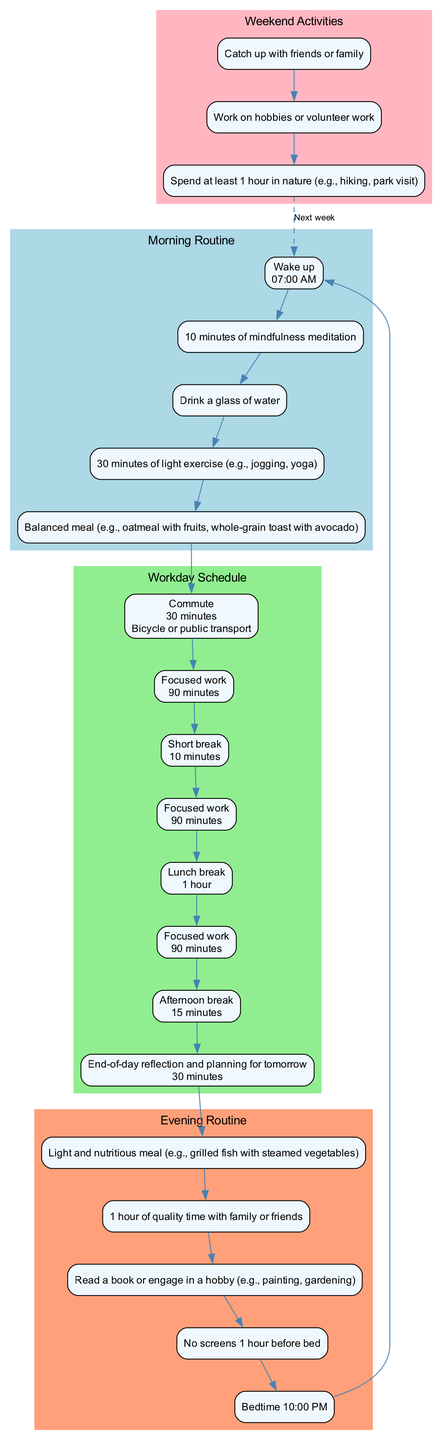What time does the morning routine start? The morning routine starts with the 'Wake up' node, which specifies the time as '07:00 AM'.
Answer: 07:00 AM How long is the lunchtime break? In the 'Workday Schedule' section, the 'Lunch break' node indicates the duration as '1 hour'.
Answer: 1 hour What is the first activity after breakfast? The flow from the 'Breakfast' node leads directly to the 'Commute' node, indicating that commuting is the first activity after breakfast.
Answer: Commute How many work blocks are present during the workday? There are seven work-related activities listed, with six defined as work blocks plus the 'End-of-day reflection and planning for tomorrow'.
Answer: 7 What activity follows family time in the evening routine? The flow from the 'Family time' node leads to the 'Relaxation' node, showing that relaxation follows family time.
Answer: Relaxation What is the mode of transportation used during the commute? The 'Commute' node contains the information that the mode of transportation is either 'Bicycle or public transport'.
Answer: Bicycle or public transport What meal is suggested for dinner during the evening routine? The 'Dinner' node specifies the meal as 'Light and nutritious meal (e.g., grilled fish with steamed vegetables)'.
Answer: Light and nutritious meal (e.g., grilled fish with steamed vegetables) How many minutes should be spent on focused work before the first short break? The first 'Focused work' block indicates a duration of '90 minutes' before the short break.
Answer: 90 minutes What is advised regarding screen time before bed? The ‘Screen time limit’ node presents the advice to have 'No screens 1 hour before bed'.
Answer: No screens 1 hour before bed 